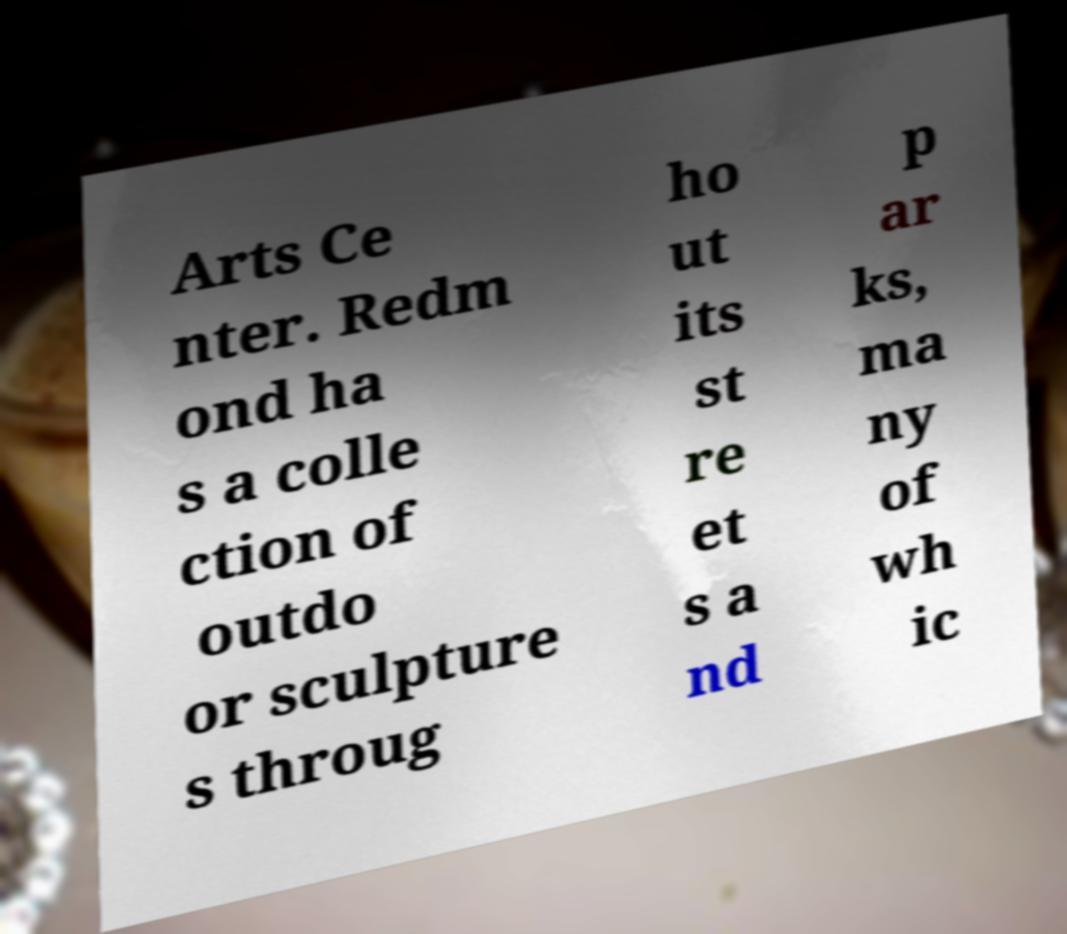What messages or text are displayed in this image? I need them in a readable, typed format. Arts Ce nter. Redm ond ha s a colle ction of outdo or sculpture s throug ho ut its st re et s a nd p ar ks, ma ny of wh ic 